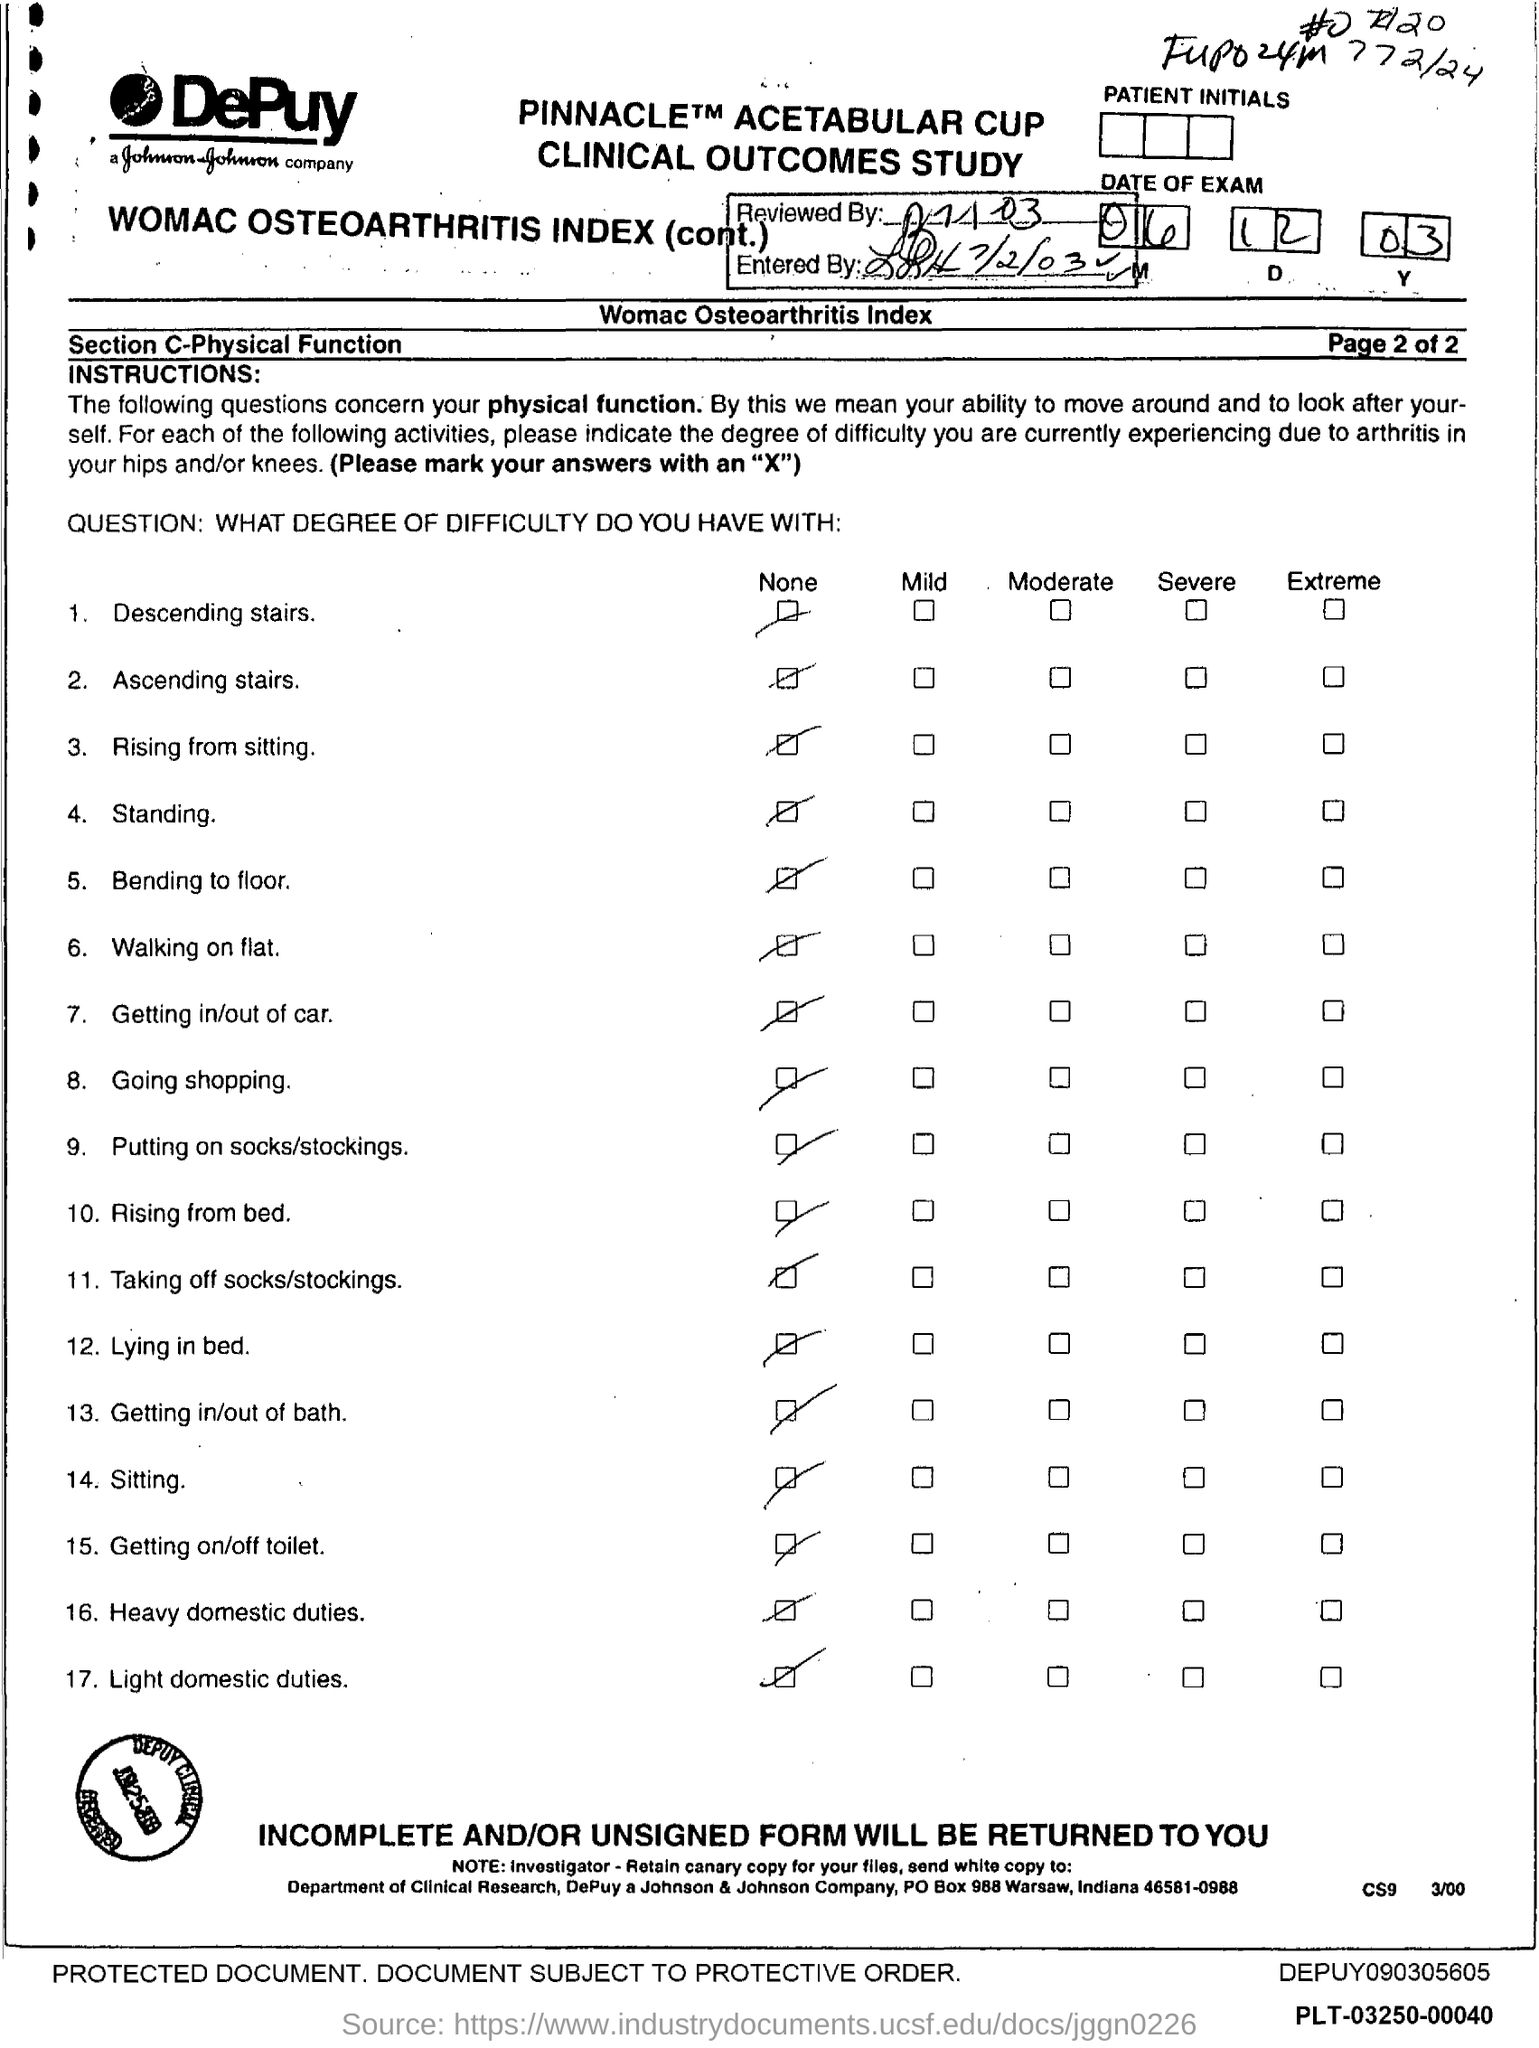The document is reviewed on which date?
Provide a short and direct response. 7/1/03. 